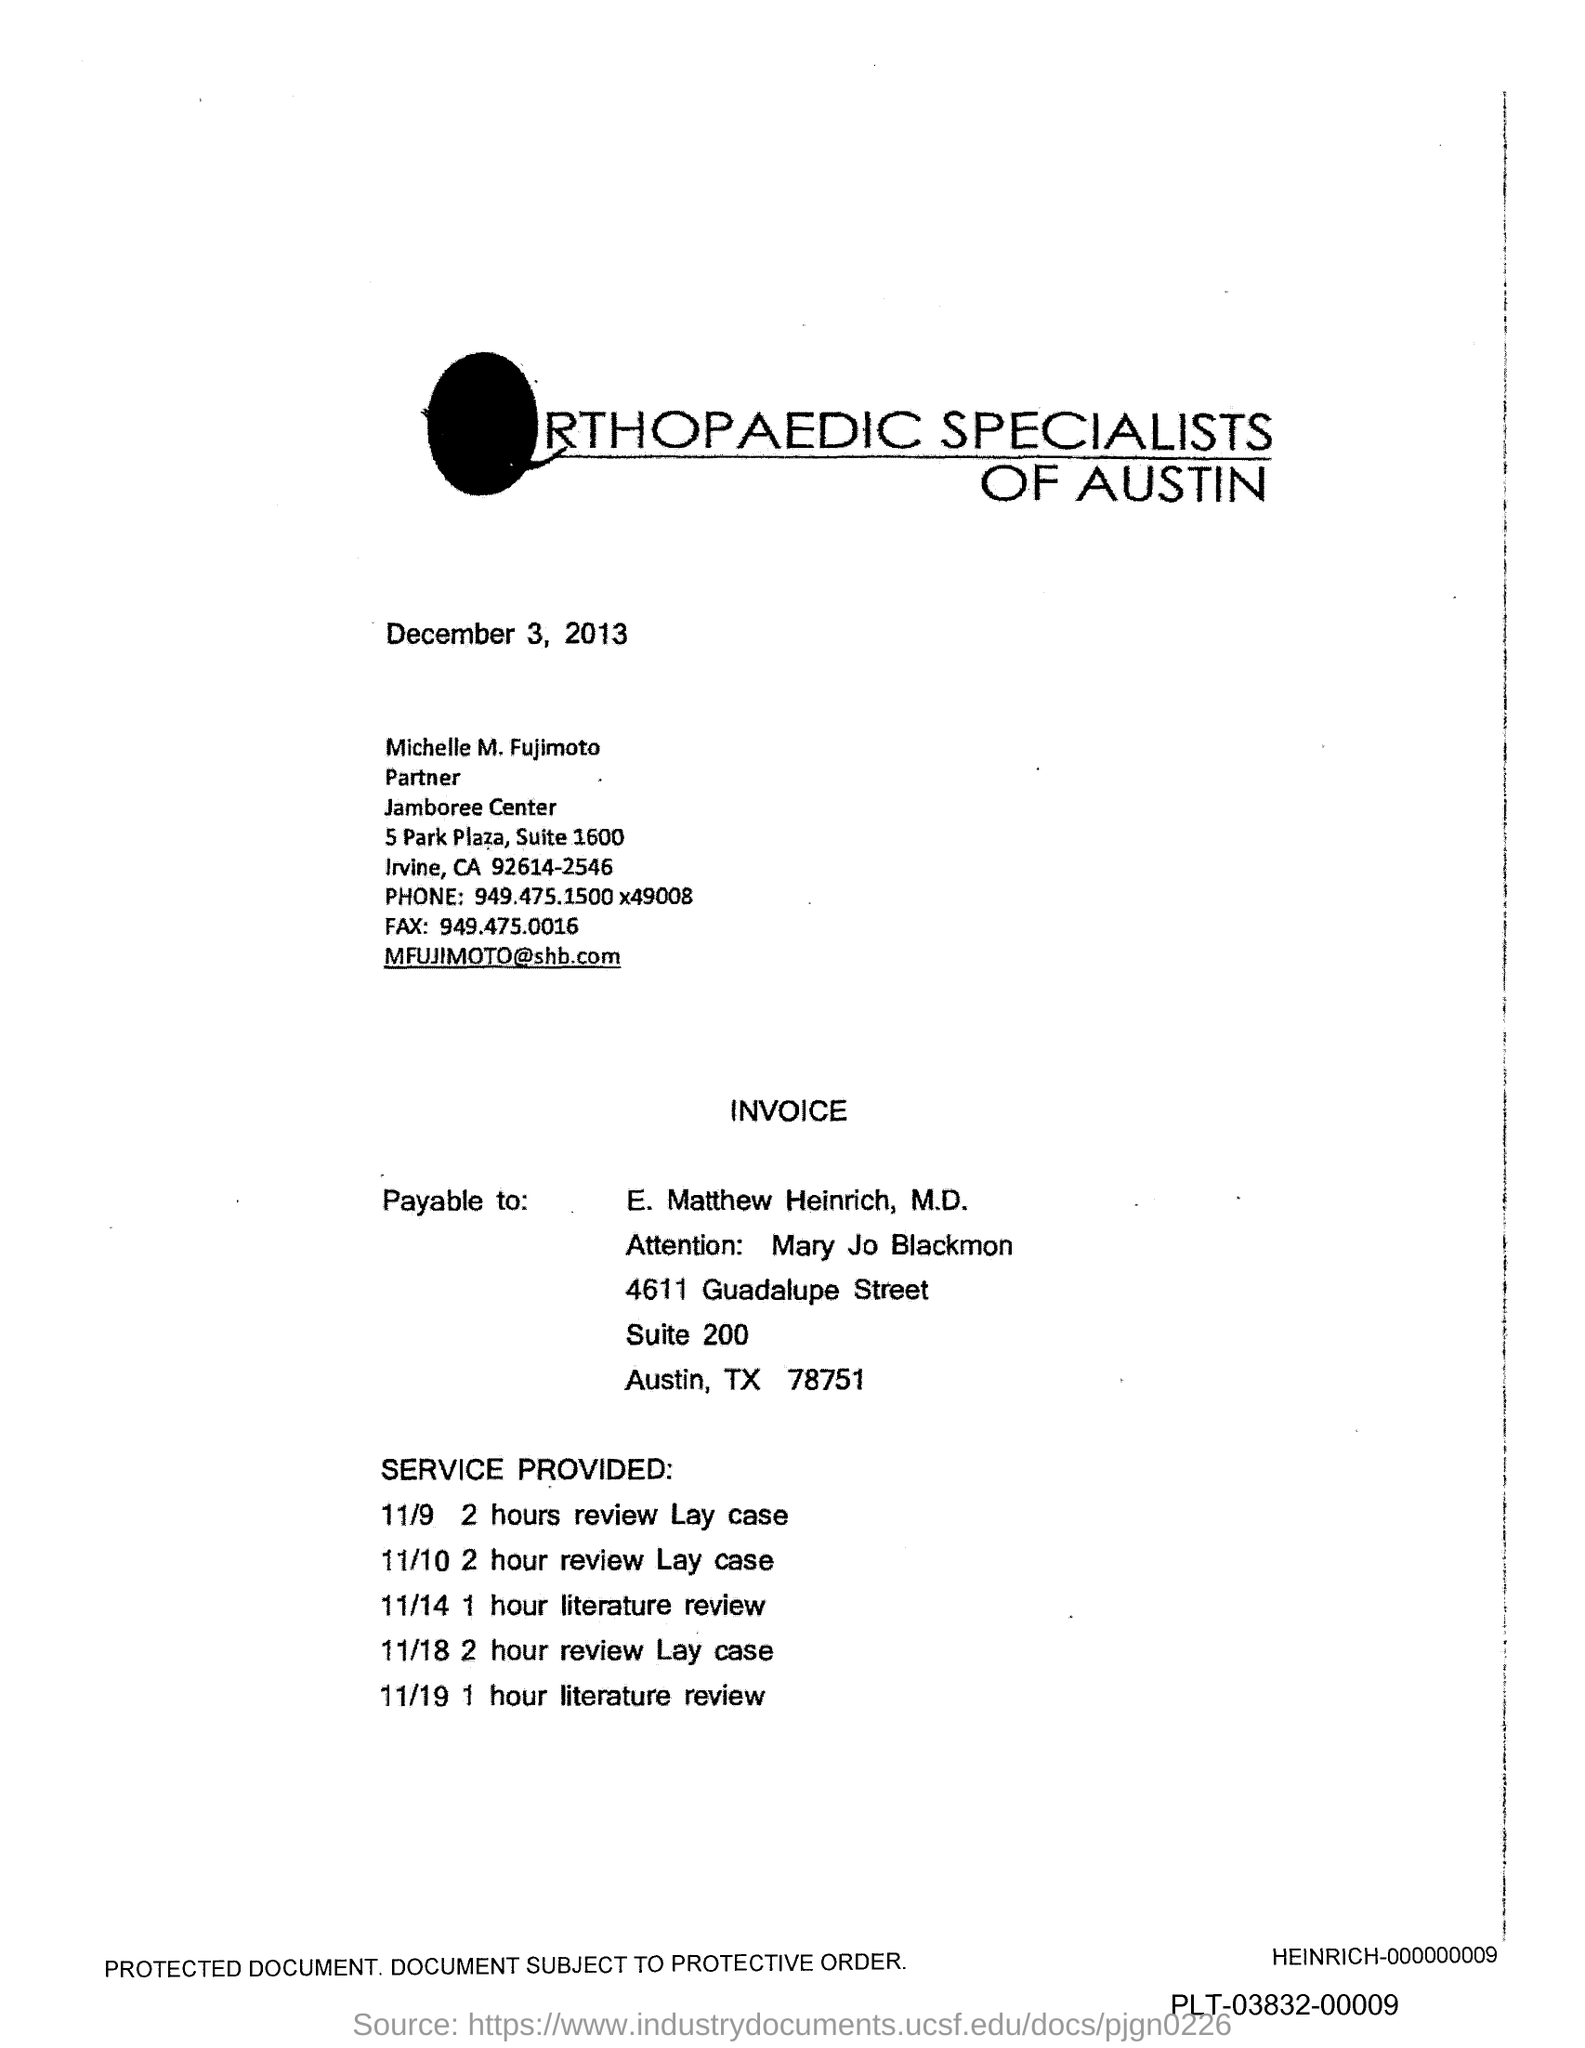What is the mail id mentioned in the document?
Make the answer very short. MFUJIMOTO@shb.com. What is the FAX number mentioned in the document?
Your answer should be very brief. 949.475.0016. 